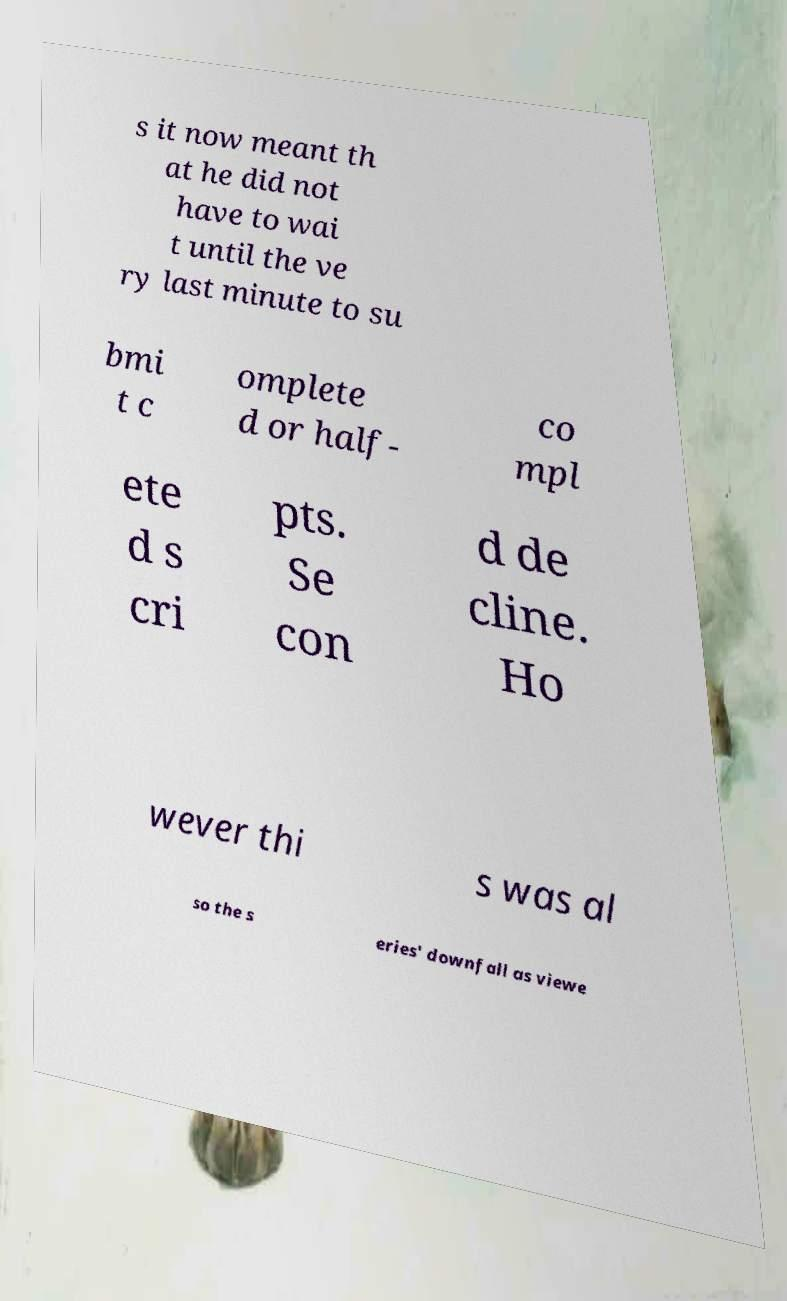For documentation purposes, I need the text within this image transcribed. Could you provide that? s it now meant th at he did not have to wai t until the ve ry last minute to su bmi t c omplete d or half- co mpl ete d s cri pts. Se con d de cline. Ho wever thi s was al so the s eries' downfall as viewe 